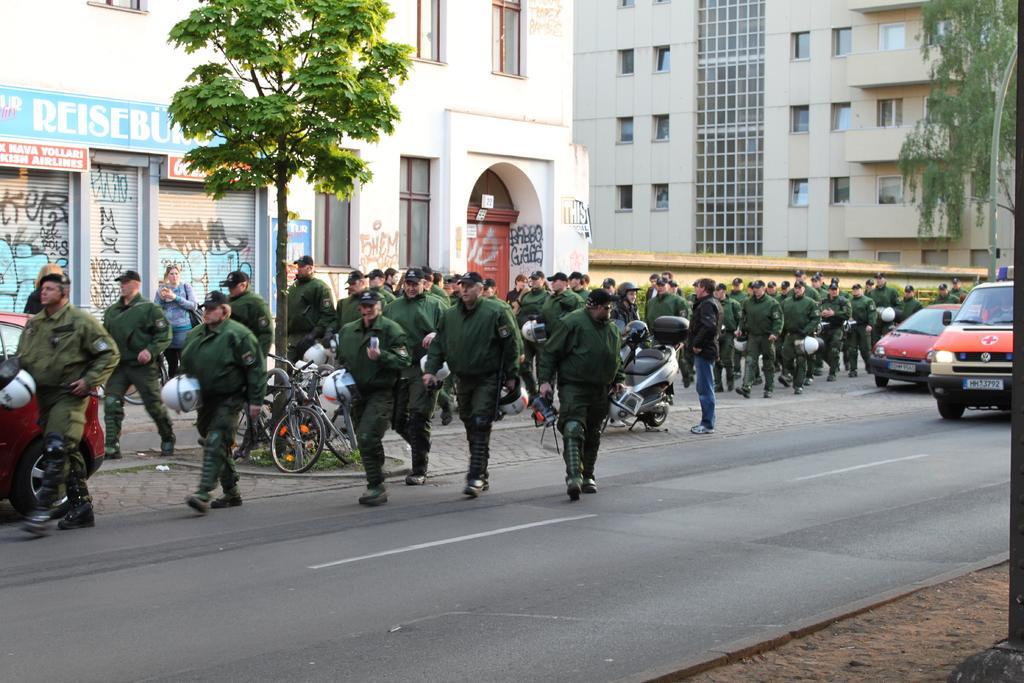Could you give a brief overview of what you see in this image? This picture consists of road , on the road I can see group of persons and vehicle on the right side and some vehicles kept on road in the middle and tree visible in the middle ,at the top I can see the building and tree on tree on the right side and I can see another vehicle on the left side. 